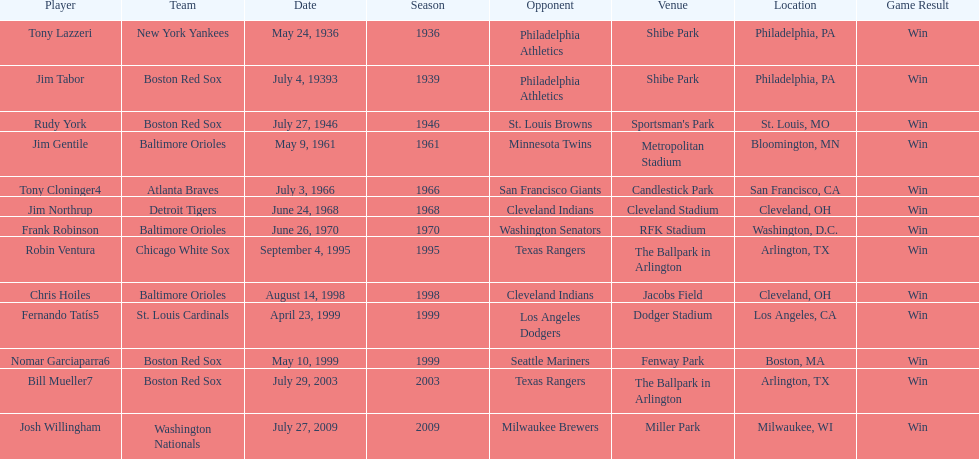What is the number of times a boston red sox player has had two grand slams in one game? 4. 